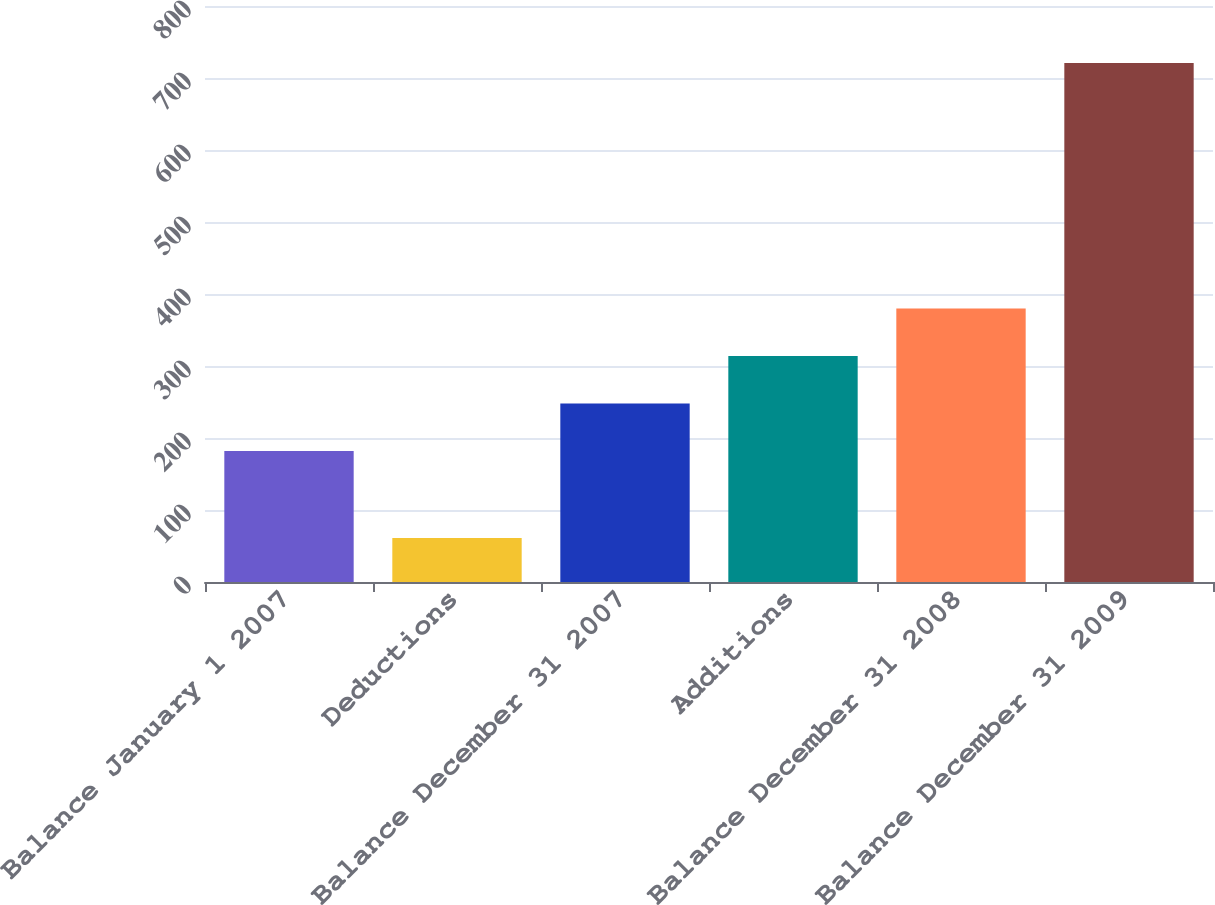Convert chart. <chart><loc_0><loc_0><loc_500><loc_500><bar_chart><fcel>Balance January 1 2007<fcel>Deductions<fcel>Balance December 31 2007<fcel>Additions<fcel>Balance December 31 2008<fcel>Balance December 31 2009<nl><fcel>182<fcel>61<fcel>248<fcel>314<fcel>380<fcel>721<nl></chart> 